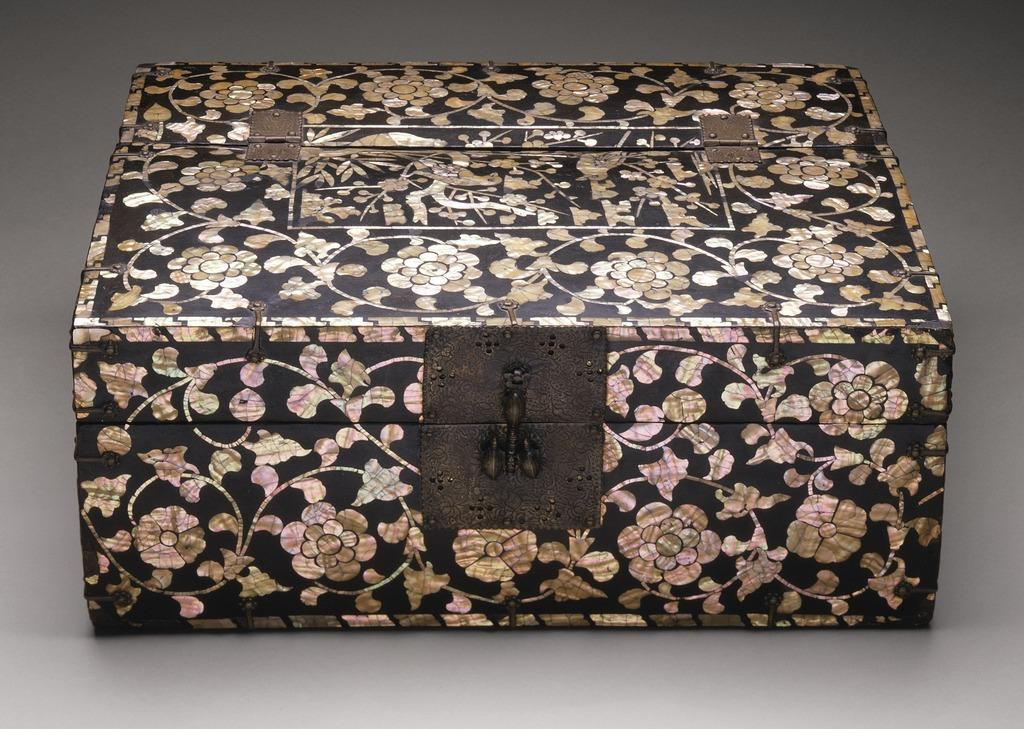What is the main object in the image? There is a box in the image. Can you describe the design on the box? The box has a floral design on it. What type of fuel is being used by the man on the train in the image? There is no man or train present in the image; it only features a box with a floral design. 